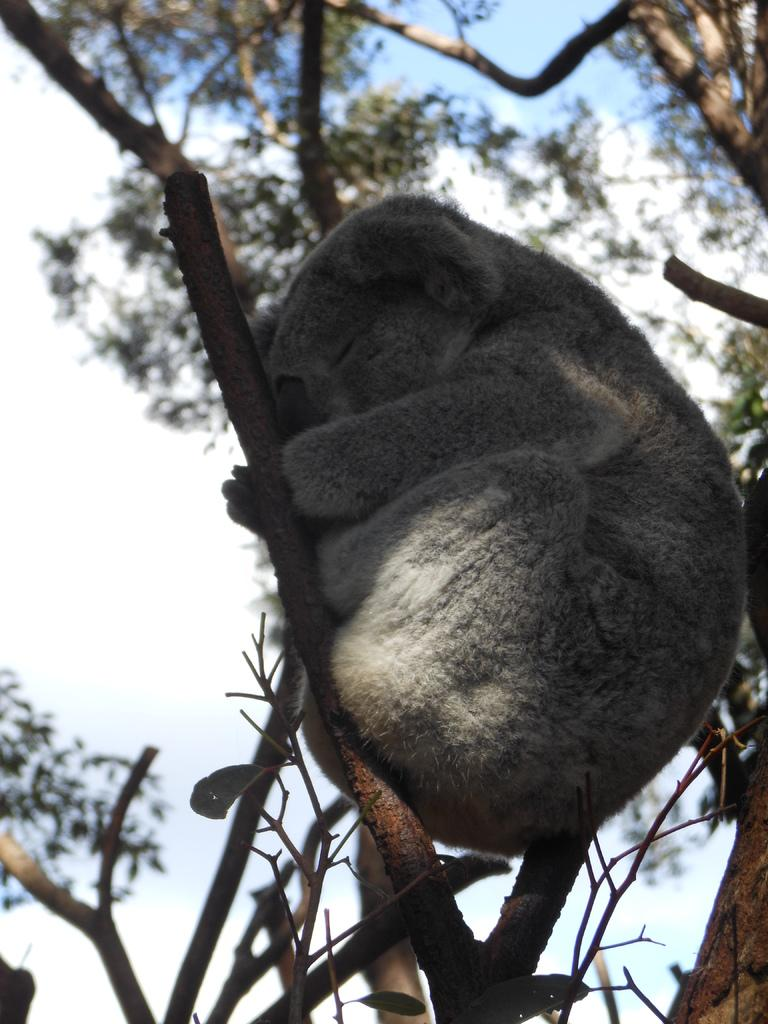What is the main subject of the image? There is an animal on a tree in the image. What can be seen in the background of the image? There are trees and the sky visible in the background of the image. How is the background of the image depicted? The background of the image is blurred. Who is the owner of the hill in the image? There is no hill present in the image, so there is no owner to consider. 